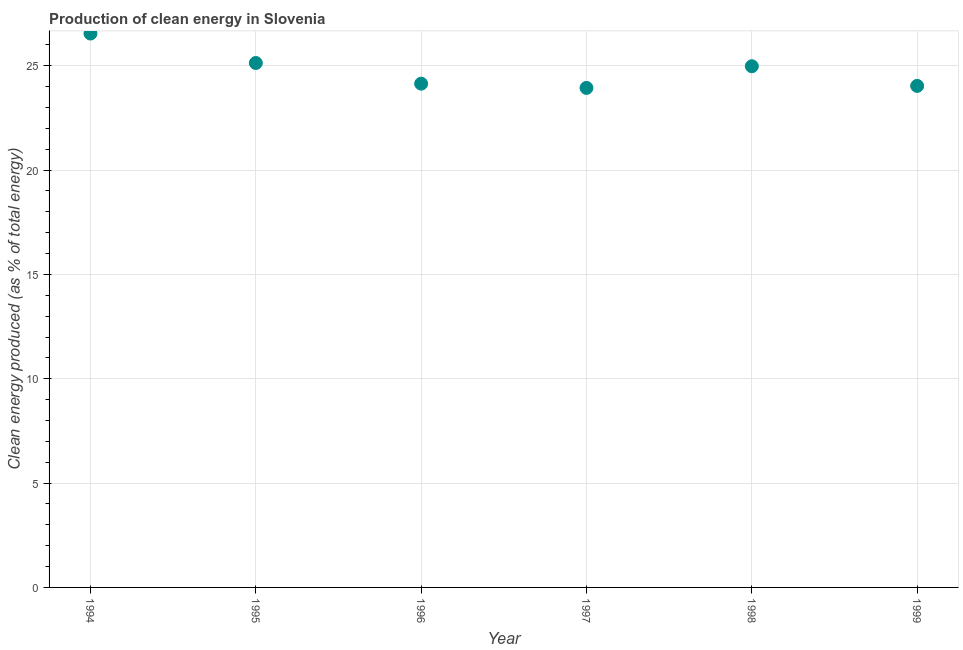What is the production of clean energy in 1998?
Keep it short and to the point. 24.98. Across all years, what is the maximum production of clean energy?
Ensure brevity in your answer.  26.55. Across all years, what is the minimum production of clean energy?
Your answer should be very brief. 23.94. In which year was the production of clean energy maximum?
Give a very brief answer. 1994. What is the sum of the production of clean energy?
Your answer should be very brief. 148.78. What is the difference between the production of clean energy in 1995 and 1998?
Your answer should be very brief. 0.16. What is the average production of clean energy per year?
Ensure brevity in your answer.  24.8. What is the median production of clean energy?
Keep it short and to the point. 24.56. Do a majority of the years between 1999 and 1998 (inclusive) have production of clean energy greater than 22 %?
Provide a succinct answer. No. What is the ratio of the production of clean energy in 1998 to that in 1999?
Ensure brevity in your answer.  1.04. What is the difference between the highest and the second highest production of clean energy?
Make the answer very short. 1.41. Is the sum of the production of clean energy in 1996 and 1997 greater than the maximum production of clean energy across all years?
Make the answer very short. Yes. What is the difference between the highest and the lowest production of clean energy?
Provide a succinct answer. 2.61. In how many years, is the production of clean energy greater than the average production of clean energy taken over all years?
Provide a succinct answer. 3. Does the production of clean energy monotonically increase over the years?
Your response must be concise. No. How many dotlines are there?
Your answer should be very brief. 1. How many years are there in the graph?
Offer a terse response. 6. What is the difference between two consecutive major ticks on the Y-axis?
Offer a terse response. 5. Does the graph contain grids?
Provide a succinct answer. Yes. What is the title of the graph?
Your response must be concise. Production of clean energy in Slovenia. What is the label or title of the X-axis?
Your answer should be compact. Year. What is the label or title of the Y-axis?
Give a very brief answer. Clean energy produced (as % of total energy). What is the Clean energy produced (as % of total energy) in 1994?
Offer a very short reply. 26.55. What is the Clean energy produced (as % of total energy) in 1995?
Provide a succinct answer. 25.13. What is the Clean energy produced (as % of total energy) in 1996?
Provide a short and direct response. 24.14. What is the Clean energy produced (as % of total energy) in 1997?
Provide a short and direct response. 23.94. What is the Clean energy produced (as % of total energy) in 1998?
Provide a succinct answer. 24.98. What is the Clean energy produced (as % of total energy) in 1999?
Provide a succinct answer. 24.04. What is the difference between the Clean energy produced (as % of total energy) in 1994 and 1995?
Your answer should be compact. 1.41. What is the difference between the Clean energy produced (as % of total energy) in 1994 and 1996?
Keep it short and to the point. 2.4. What is the difference between the Clean energy produced (as % of total energy) in 1994 and 1997?
Provide a short and direct response. 2.61. What is the difference between the Clean energy produced (as % of total energy) in 1994 and 1998?
Make the answer very short. 1.57. What is the difference between the Clean energy produced (as % of total energy) in 1994 and 1999?
Your response must be concise. 2.51. What is the difference between the Clean energy produced (as % of total energy) in 1995 and 1996?
Make the answer very short. 0.99. What is the difference between the Clean energy produced (as % of total energy) in 1995 and 1997?
Provide a short and direct response. 1.19. What is the difference between the Clean energy produced (as % of total energy) in 1995 and 1998?
Your response must be concise. 0.16. What is the difference between the Clean energy produced (as % of total energy) in 1995 and 1999?
Provide a short and direct response. 1.1. What is the difference between the Clean energy produced (as % of total energy) in 1996 and 1997?
Give a very brief answer. 0.2. What is the difference between the Clean energy produced (as % of total energy) in 1996 and 1998?
Keep it short and to the point. -0.83. What is the difference between the Clean energy produced (as % of total energy) in 1996 and 1999?
Ensure brevity in your answer.  0.11. What is the difference between the Clean energy produced (as % of total energy) in 1997 and 1998?
Provide a succinct answer. -1.04. What is the difference between the Clean energy produced (as % of total energy) in 1997 and 1999?
Give a very brief answer. -0.1. What is the difference between the Clean energy produced (as % of total energy) in 1998 and 1999?
Provide a succinct answer. 0.94. What is the ratio of the Clean energy produced (as % of total energy) in 1994 to that in 1995?
Keep it short and to the point. 1.06. What is the ratio of the Clean energy produced (as % of total energy) in 1994 to that in 1996?
Give a very brief answer. 1.1. What is the ratio of the Clean energy produced (as % of total energy) in 1994 to that in 1997?
Keep it short and to the point. 1.11. What is the ratio of the Clean energy produced (as % of total energy) in 1994 to that in 1998?
Your answer should be very brief. 1.06. What is the ratio of the Clean energy produced (as % of total energy) in 1994 to that in 1999?
Offer a terse response. 1.1. What is the ratio of the Clean energy produced (as % of total energy) in 1995 to that in 1996?
Provide a succinct answer. 1.04. What is the ratio of the Clean energy produced (as % of total energy) in 1995 to that in 1999?
Provide a succinct answer. 1.05. What is the ratio of the Clean energy produced (as % of total energy) in 1996 to that in 1997?
Your answer should be very brief. 1.01. What is the ratio of the Clean energy produced (as % of total energy) in 1996 to that in 1998?
Offer a very short reply. 0.97. What is the ratio of the Clean energy produced (as % of total energy) in 1997 to that in 1998?
Offer a very short reply. 0.96. What is the ratio of the Clean energy produced (as % of total energy) in 1998 to that in 1999?
Your answer should be compact. 1.04. 